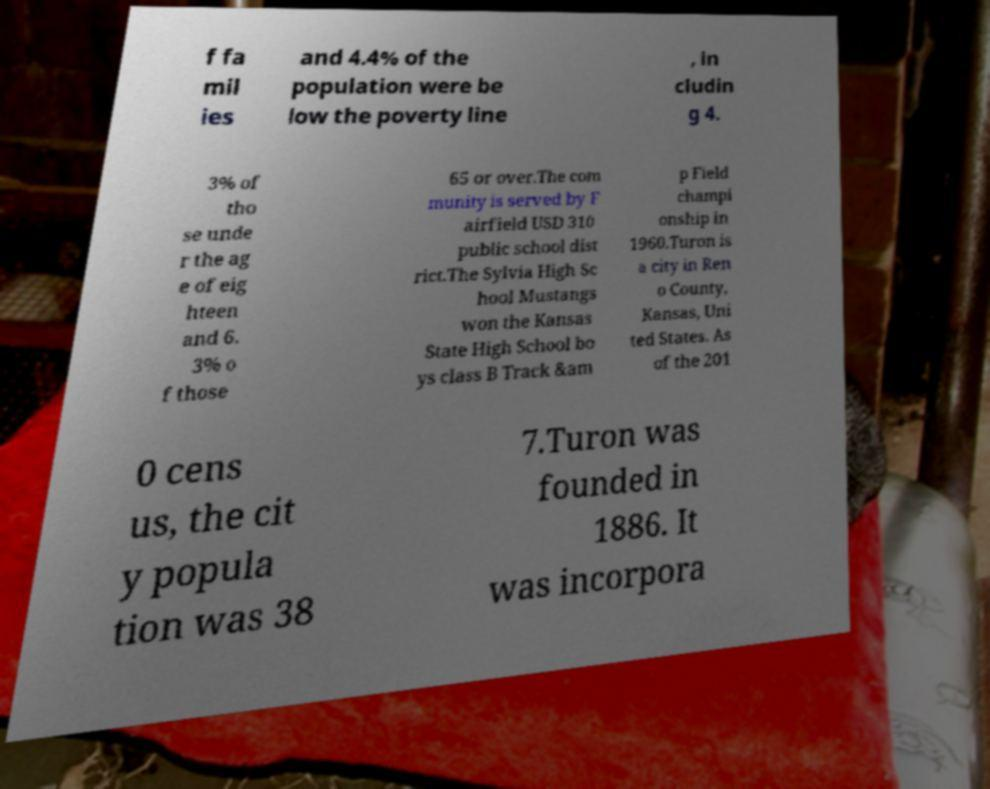Could you extract and type out the text from this image? f fa mil ies and 4.4% of the population were be low the poverty line , in cludin g 4. 3% of tho se unde r the ag e of eig hteen and 6. 3% o f those 65 or over.The com munity is served by F airfield USD 310 public school dist rict.The Sylvia High Sc hool Mustangs won the Kansas State High School bo ys class B Track &am p Field champi onship in 1960.Turon is a city in Ren o County, Kansas, Uni ted States. As of the 201 0 cens us, the cit y popula tion was 38 7.Turon was founded in 1886. It was incorpora 